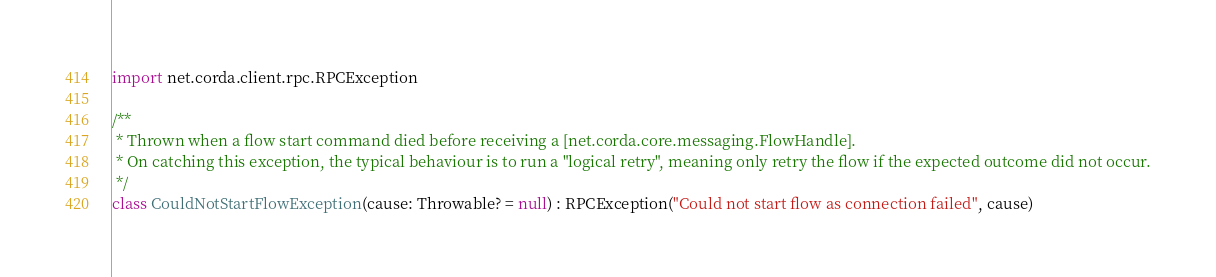<code> <loc_0><loc_0><loc_500><loc_500><_Kotlin_>
import net.corda.client.rpc.RPCException

/**
 * Thrown when a flow start command died before receiving a [net.corda.core.messaging.FlowHandle].
 * On catching this exception, the typical behaviour is to run a "logical retry", meaning only retry the flow if the expected outcome did not occur.
 */
class CouldNotStartFlowException(cause: Throwable? = null) : RPCException("Could not start flow as connection failed", cause)

</code> 